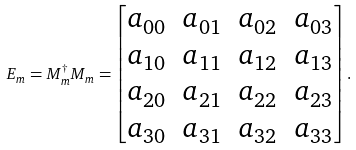Convert formula to latex. <formula><loc_0><loc_0><loc_500><loc_500>E _ { m } = M _ { m } ^ { \dagger } M _ { m } = \begin{bmatrix} a _ { 0 0 } & a _ { 0 1 } & a _ { 0 2 } & a _ { 0 3 } \\ a _ { 1 0 } & a _ { 1 1 } & a _ { 1 2 } & a _ { 1 3 } \\ a _ { 2 0 } & a _ { 2 1 } & a _ { 2 2 } & a _ { 2 3 } \\ a _ { 3 0 } & a _ { 3 1 } & a _ { 3 2 } & a _ { 3 3 } \end{bmatrix} .</formula> 